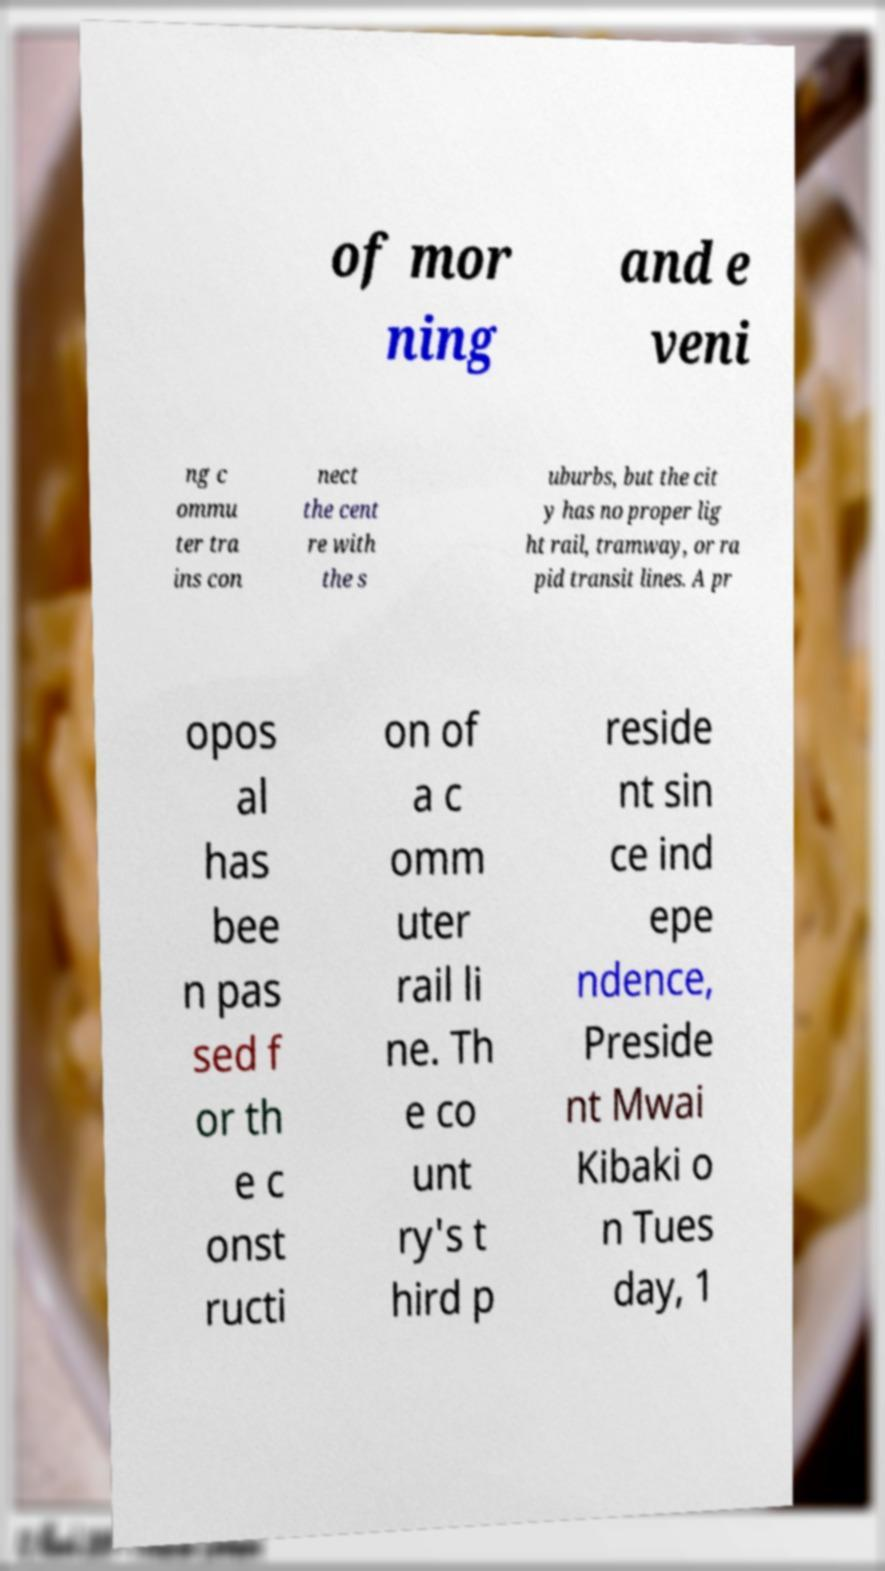There's text embedded in this image that I need extracted. Can you transcribe it verbatim? of mor ning and e veni ng c ommu ter tra ins con nect the cent re with the s uburbs, but the cit y has no proper lig ht rail, tramway, or ra pid transit lines. A pr opos al has bee n pas sed f or th e c onst ructi on of a c omm uter rail li ne. Th e co unt ry's t hird p reside nt sin ce ind epe ndence, Preside nt Mwai Kibaki o n Tues day, 1 